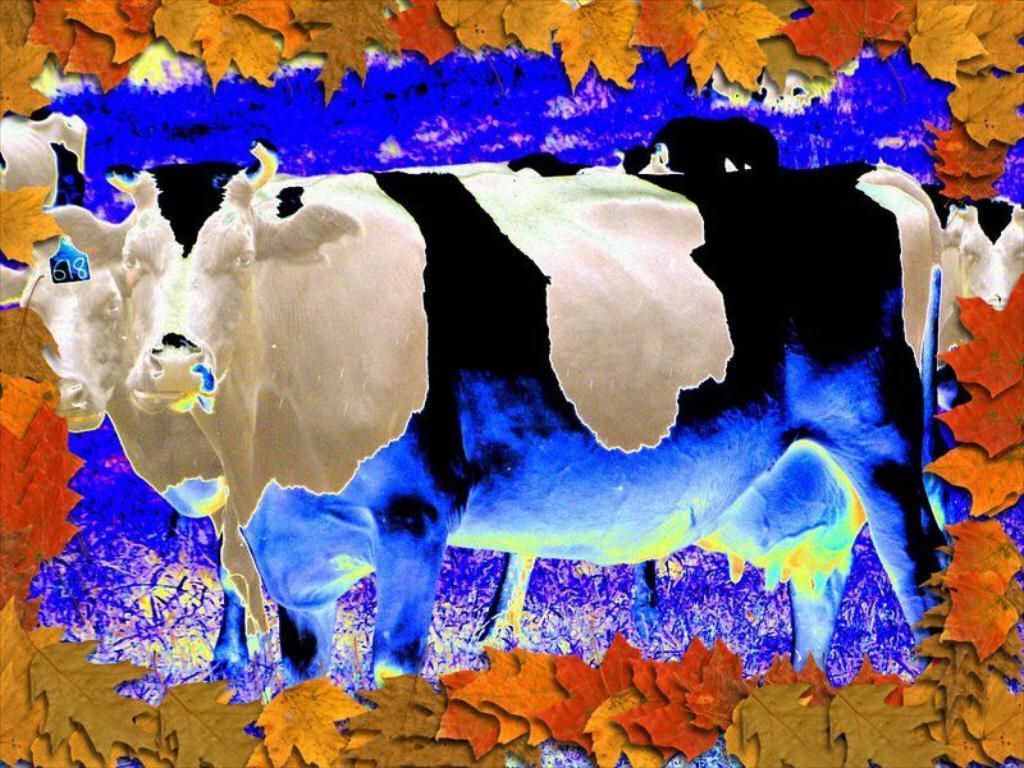What is the main subject in the center of the image? There is an animal in the center of the image. What type of terrain is visible in the image? There is grass on the ground in the image. What type of vegetation can be seen in the image? There are leaves in the image. What colors are present in the objects in the image? There are white and blue objects in the image. What sense does the animal use to detect the chess pieces in the image? There are no chess pieces present in the image, and therefore the animal does not need to use any sense to detect them. 